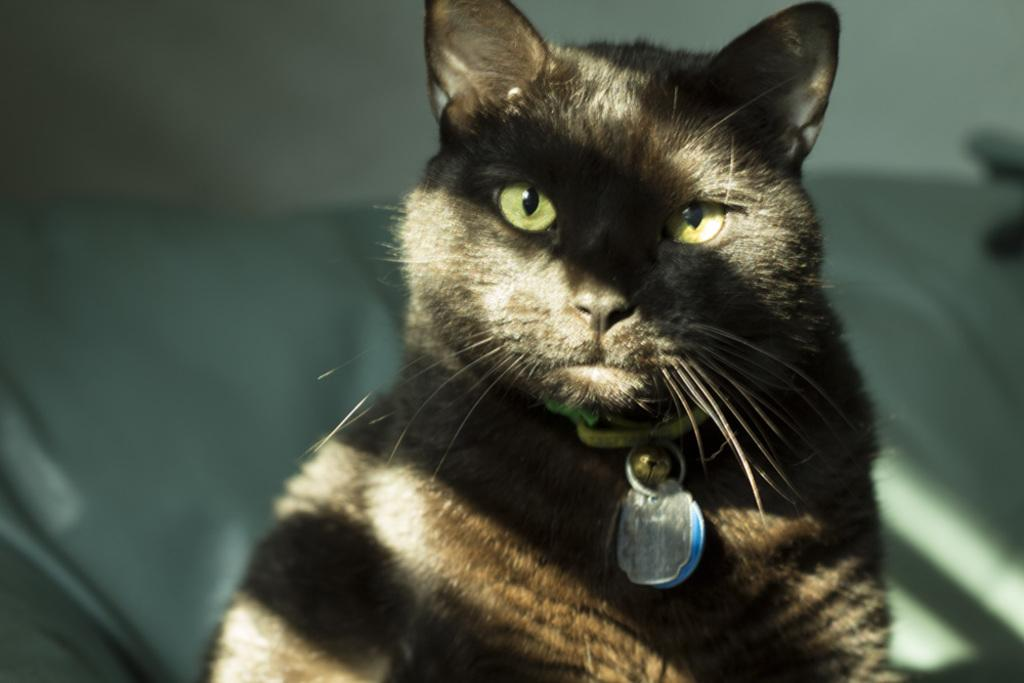What animal can be seen in the picture? There is a cat in the picture. Where is the cat located in the image? The cat is sitting on a sofa. What can be seen in the background of the picture? There is a wall visible in the background of the picture. What type of straw is the cat using to build a shelter in the image? There is no straw present in the image, and the cat is not building a shelter. 